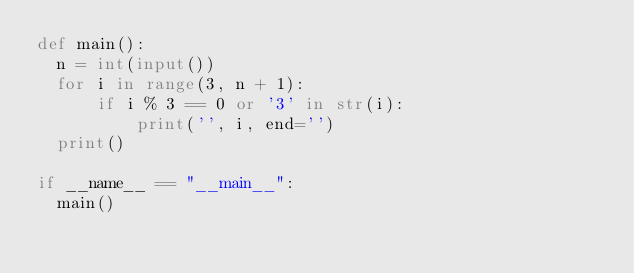<code> <loc_0><loc_0><loc_500><loc_500><_Python_>def main():
  n = int(input())
  for i in range(3, n + 1):
      if i % 3 == 0 or '3' in str(i):
          print('', i, end='')
  print()
  
if __name__ == "__main__":
  main()

</code> 